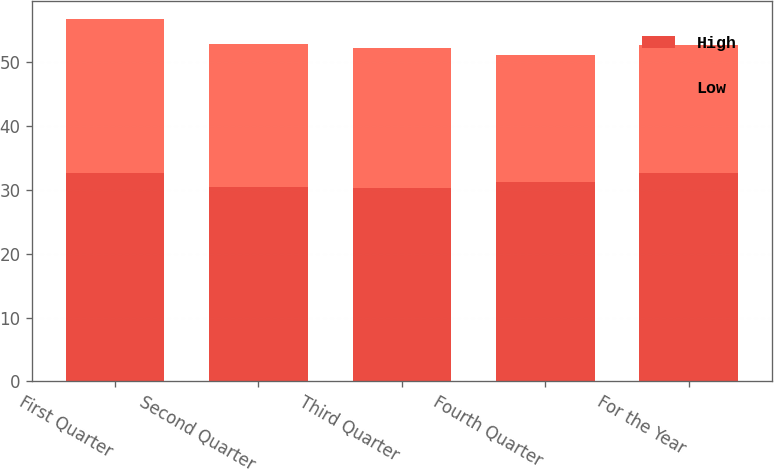<chart> <loc_0><loc_0><loc_500><loc_500><stacked_bar_chart><ecel><fcel>First Quarter<fcel>Second Quarter<fcel>Third Quarter<fcel>Fourth Quarter<fcel>For the Year<nl><fcel>High<fcel>32.68<fcel>30.5<fcel>30.38<fcel>31.18<fcel>32.68<nl><fcel>Low<fcel>24.08<fcel>22.32<fcel>21.92<fcel>20<fcel>20<nl></chart> 